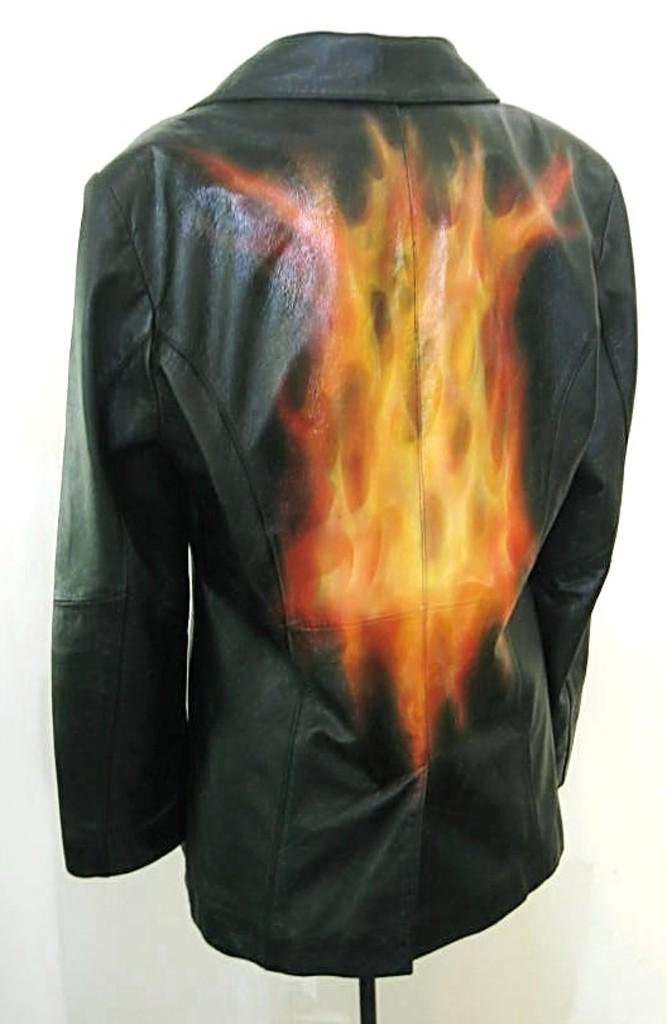What type of clothing item is present in the image? There is a shirt in the image. Can you describe the design on the shirt? The shirt has a fire type design on the back. How many dogs are present in the image? There are no dogs present in the image; it only features a shirt with a fire type design on the back. What type of advice can be seen written on the shirt? There is no advice visible on the shirt; it only has a fire type design on the back. 